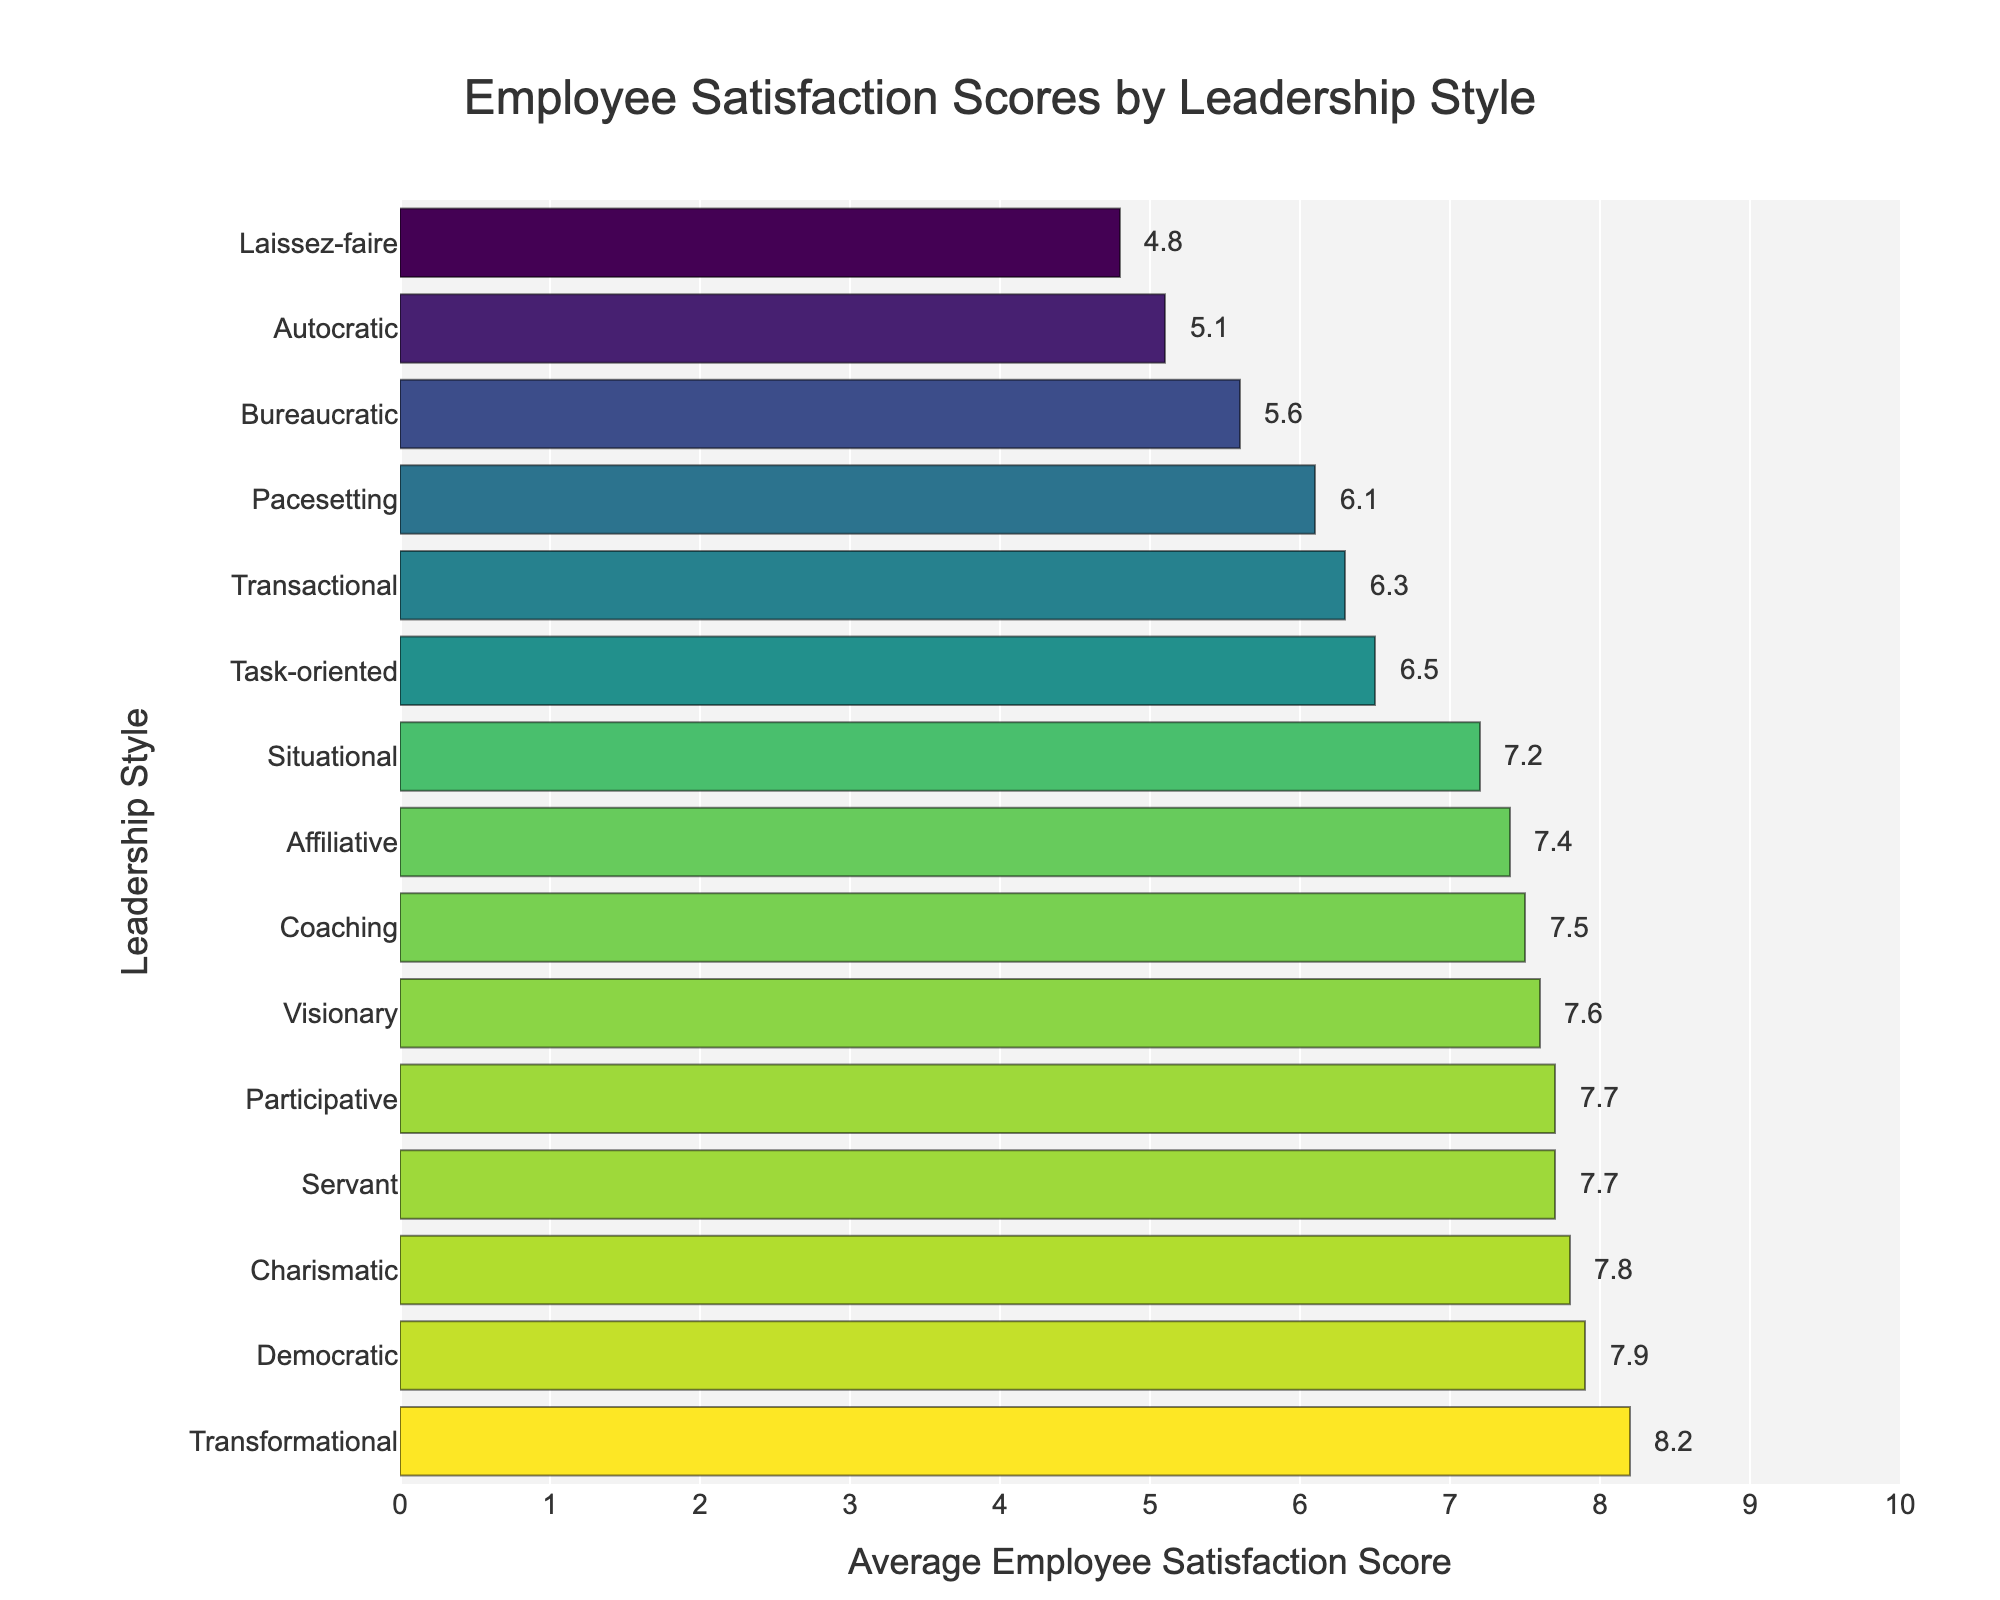What's the highest average employee satisfaction score and which leadership style does it correspond to? The highest bar represents the maximum average satisfaction score. The bar labeled "Transformational" is the tallest with a score of 8.2.
Answer: 8.2, Transformational What's the difference in average satisfaction scores between Transformational and Autocratic leadership styles? The average satisfaction score for Transformational is 8.2 and for Autocratic is 5.1. The difference is calculated as 8.2 - 5.1.
Answer: 3.1 Which leadership style has the second-lowest average satisfaction score? The bars are sorted in descending order of satisfaction score. The second shortest bar, above Laissez-faire, is labeled "Autocratic."
Answer: Autocratic How many leadership styles have an average satisfaction score above 7? Identify all bars with satisfaction scores above 7. These include Transformational, Democratic, Charismatic, Visionary, Servant, Participative, Coaching, and Affiliative (8 in total).
Answer: 8 What is the combined average satisfaction score of Democratic and Affiliative leadership styles? The satisfaction score for Democratic is 7.9, and for Affiliative is 7.4. The combined score is calculated as 7.9 + 7.4.
Answer: 15.3 Which leadership styles have a satisfaction score greater than that of Task-oriented but less than that of Charismatic? The Task-oriented score is 6.5, and the Charismatic score is 7.8. Leadership styles within this range include Participative (7.7), Servant (7.7), Visionary (7.6), and Coaching (7.5).
Answer: Participative, Servant, Visionary, Coaching Describe the visual appearance of the bar corresponding to the Transactional leadership style. The bar for Transactional is shorter than those of Transformational and Democratic, but taller than the bars for Bureaucratic and Pacesetting. It is around the middle in height and yellow-green in color.
Answer: Yellow-green, middle height 